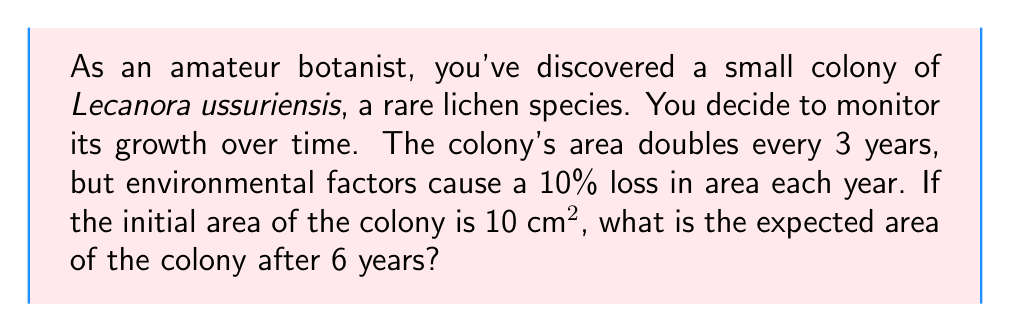Can you answer this question? Let's approach this step-by-step:

1) First, let's consider the growth without the annual loss:
   - Initial area: $A_0 = 10$ cm²
   - After 3 years: $A_3 = 20$ cm²
   - After 6 years: $A_6 = 40$ cm²

2) Now, let's factor in the annual 10% loss:
   - Each year, the area is multiplied by 0.9 (90% of the original)
   - Over 6 years, this factor is applied 6 times

3) We can express this mathematically as:
   $$A_6 = 40 \cdot (0.9)^6$$

4) Let's calculate this:
   $$A_6 = 40 \cdot (0.9)^6 = 40 \cdot 0.531441 = 21.25764 \text{ cm²}$$

5) Therefore, the expected area after 6 years is approximately 21.26 cm².
Answer: 21.26 cm² 